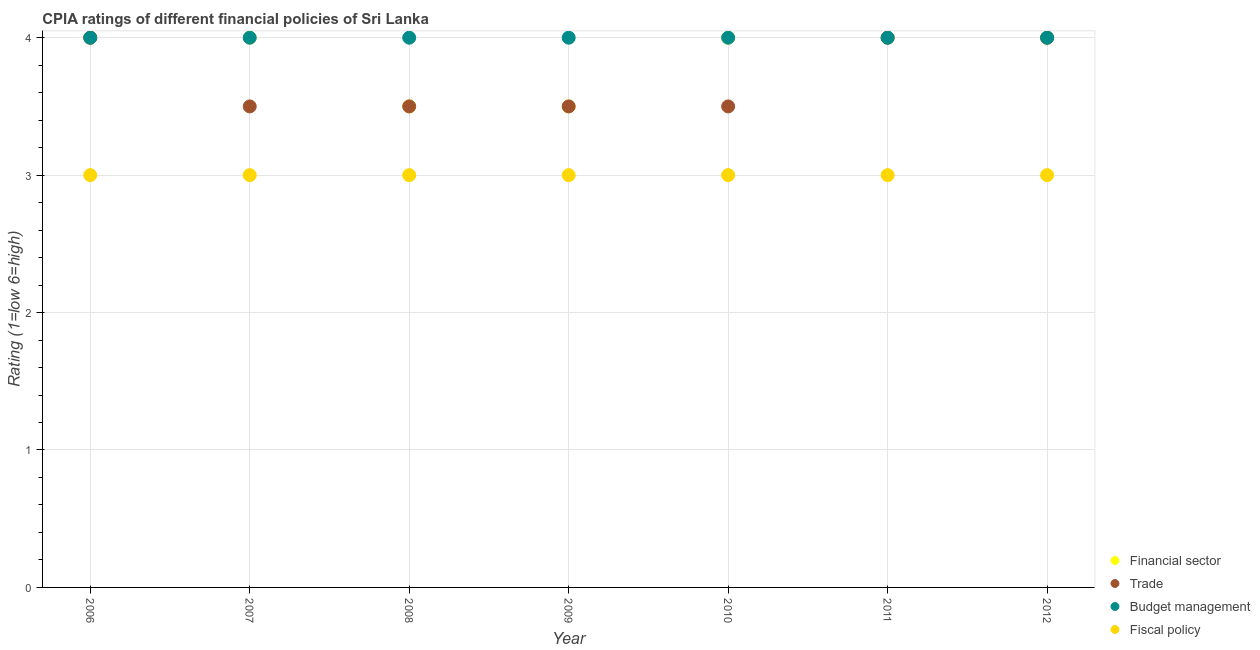What is the cpia rating of fiscal policy in 2010?
Give a very brief answer. 3. Across all years, what is the maximum cpia rating of trade?
Make the answer very short. 4. Across all years, what is the minimum cpia rating of fiscal policy?
Offer a terse response. 3. What is the total cpia rating of budget management in the graph?
Your answer should be very brief. 28. What is the difference between the cpia rating of trade in 2006 and that in 2012?
Your answer should be very brief. 0. What is the difference between the cpia rating of budget management in 2010 and the cpia rating of financial sector in 2008?
Give a very brief answer. 0.5. In how many years, is the cpia rating of financial sector greater than 0.2?
Provide a short and direct response. 7. What is the ratio of the cpia rating of financial sector in 2010 to that in 2011?
Provide a short and direct response. 1. What is the difference between the highest and the lowest cpia rating of financial sector?
Ensure brevity in your answer.  0.5. In how many years, is the cpia rating of trade greater than the average cpia rating of trade taken over all years?
Provide a succinct answer. 3. Is the sum of the cpia rating of fiscal policy in 2006 and 2010 greater than the maximum cpia rating of trade across all years?
Your answer should be compact. Yes. Is it the case that in every year, the sum of the cpia rating of financial sector and cpia rating of trade is greater than the cpia rating of budget management?
Offer a very short reply. Yes. Is the cpia rating of trade strictly less than the cpia rating of budget management over the years?
Offer a very short reply. No. How many dotlines are there?
Your answer should be compact. 4. How many years are there in the graph?
Your answer should be compact. 7. Are the values on the major ticks of Y-axis written in scientific E-notation?
Your answer should be very brief. No. How many legend labels are there?
Provide a succinct answer. 4. What is the title of the graph?
Keep it short and to the point. CPIA ratings of different financial policies of Sri Lanka. What is the label or title of the Y-axis?
Provide a short and direct response. Rating (1=low 6=high). What is the Rating (1=low 6=high) of Financial sector in 2006?
Provide a succinct answer. 4. What is the Rating (1=low 6=high) in Budget management in 2006?
Provide a succinct answer. 4. What is the Rating (1=low 6=high) in Fiscal policy in 2006?
Make the answer very short. 3. What is the Rating (1=low 6=high) in Financial sector in 2007?
Offer a terse response. 4. What is the Rating (1=low 6=high) of Budget management in 2008?
Offer a very short reply. 4. What is the Rating (1=low 6=high) of Fiscal policy in 2008?
Your answer should be very brief. 3. What is the Rating (1=low 6=high) of Trade in 2009?
Your response must be concise. 3.5. What is the Rating (1=low 6=high) in Budget management in 2009?
Your answer should be compact. 4. What is the Rating (1=low 6=high) of Fiscal policy in 2009?
Your answer should be compact. 3. What is the Rating (1=low 6=high) of Trade in 2010?
Ensure brevity in your answer.  3.5. What is the Rating (1=low 6=high) in Fiscal policy in 2010?
Keep it short and to the point. 3. What is the Rating (1=low 6=high) of Financial sector in 2011?
Provide a succinct answer. 4. What is the Rating (1=low 6=high) in Fiscal policy in 2011?
Provide a succinct answer. 3. What is the Rating (1=low 6=high) of Financial sector in 2012?
Offer a terse response. 4. What is the Rating (1=low 6=high) of Trade in 2012?
Your answer should be compact. 4. Across all years, what is the maximum Rating (1=low 6=high) in Financial sector?
Offer a very short reply. 4. Across all years, what is the maximum Rating (1=low 6=high) in Fiscal policy?
Offer a very short reply. 3. Across all years, what is the minimum Rating (1=low 6=high) of Financial sector?
Your response must be concise. 3.5. What is the total Rating (1=low 6=high) of Trade in the graph?
Make the answer very short. 26. What is the total Rating (1=low 6=high) of Budget management in the graph?
Offer a terse response. 28. What is the total Rating (1=low 6=high) in Fiscal policy in the graph?
Make the answer very short. 21. What is the difference between the Rating (1=low 6=high) of Fiscal policy in 2006 and that in 2007?
Make the answer very short. 0. What is the difference between the Rating (1=low 6=high) in Fiscal policy in 2006 and that in 2008?
Provide a short and direct response. 0. What is the difference between the Rating (1=low 6=high) of Financial sector in 2006 and that in 2009?
Your answer should be very brief. 0.5. What is the difference between the Rating (1=low 6=high) of Fiscal policy in 2006 and that in 2009?
Make the answer very short. 0. What is the difference between the Rating (1=low 6=high) in Financial sector in 2006 and that in 2010?
Your answer should be very brief. 0. What is the difference between the Rating (1=low 6=high) in Trade in 2006 and that in 2010?
Offer a terse response. 0.5. What is the difference between the Rating (1=low 6=high) in Financial sector in 2006 and that in 2011?
Give a very brief answer. 0. What is the difference between the Rating (1=low 6=high) in Trade in 2006 and that in 2011?
Provide a short and direct response. 0. What is the difference between the Rating (1=low 6=high) of Financial sector in 2006 and that in 2012?
Make the answer very short. 0. What is the difference between the Rating (1=low 6=high) in Trade in 2006 and that in 2012?
Your response must be concise. 0. What is the difference between the Rating (1=low 6=high) in Budget management in 2006 and that in 2012?
Your answer should be compact. 0. What is the difference between the Rating (1=low 6=high) of Financial sector in 2007 and that in 2008?
Offer a very short reply. 0.5. What is the difference between the Rating (1=low 6=high) of Financial sector in 2007 and that in 2009?
Offer a terse response. 0.5. What is the difference between the Rating (1=low 6=high) in Fiscal policy in 2007 and that in 2009?
Keep it short and to the point. 0. What is the difference between the Rating (1=low 6=high) in Financial sector in 2007 and that in 2010?
Make the answer very short. 0. What is the difference between the Rating (1=low 6=high) in Trade in 2007 and that in 2010?
Ensure brevity in your answer.  0. What is the difference between the Rating (1=low 6=high) in Fiscal policy in 2007 and that in 2010?
Offer a very short reply. 0. What is the difference between the Rating (1=low 6=high) of Financial sector in 2007 and that in 2011?
Ensure brevity in your answer.  0. What is the difference between the Rating (1=low 6=high) in Financial sector in 2007 and that in 2012?
Provide a succinct answer. 0. What is the difference between the Rating (1=low 6=high) in Budget management in 2007 and that in 2012?
Your response must be concise. 0. What is the difference between the Rating (1=low 6=high) in Financial sector in 2008 and that in 2009?
Give a very brief answer. 0. What is the difference between the Rating (1=low 6=high) in Budget management in 2008 and that in 2009?
Provide a short and direct response. 0. What is the difference between the Rating (1=low 6=high) in Fiscal policy in 2008 and that in 2010?
Your response must be concise. 0. What is the difference between the Rating (1=low 6=high) of Financial sector in 2008 and that in 2011?
Give a very brief answer. -0.5. What is the difference between the Rating (1=low 6=high) of Trade in 2008 and that in 2011?
Your answer should be very brief. -0.5. What is the difference between the Rating (1=low 6=high) of Fiscal policy in 2008 and that in 2011?
Ensure brevity in your answer.  0. What is the difference between the Rating (1=low 6=high) of Financial sector in 2008 and that in 2012?
Your response must be concise. -0.5. What is the difference between the Rating (1=low 6=high) of Trade in 2008 and that in 2012?
Provide a short and direct response. -0.5. What is the difference between the Rating (1=low 6=high) of Budget management in 2008 and that in 2012?
Offer a terse response. 0. What is the difference between the Rating (1=low 6=high) in Financial sector in 2009 and that in 2010?
Your answer should be compact. -0.5. What is the difference between the Rating (1=low 6=high) in Fiscal policy in 2009 and that in 2010?
Offer a terse response. 0. What is the difference between the Rating (1=low 6=high) in Budget management in 2009 and that in 2011?
Your response must be concise. 0. What is the difference between the Rating (1=low 6=high) of Trade in 2009 and that in 2012?
Provide a short and direct response. -0.5. What is the difference between the Rating (1=low 6=high) in Budget management in 2009 and that in 2012?
Give a very brief answer. 0. What is the difference between the Rating (1=low 6=high) in Fiscal policy in 2009 and that in 2012?
Offer a terse response. 0. What is the difference between the Rating (1=low 6=high) in Budget management in 2010 and that in 2011?
Provide a short and direct response. 0. What is the difference between the Rating (1=low 6=high) in Fiscal policy in 2010 and that in 2011?
Your response must be concise. 0. What is the difference between the Rating (1=low 6=high) in Financial sector in 2011 and that in 2012?
Provide a succinct answer. 0. What is the difference between the Rating (1=low 6=high) in Budget management in 2011 and that in 2012?
Offer a very short reply. 0. What is the difference between the Rating (1=low 6=high) of Fiscal policy in 2011 and that in 2012?
Keep it short and to the point. 0. What is the difference between the Rating (1=low 6=high) in Financial sector in 2006 and the Rating (1=low 6=high) in Budget management in 2007?
Give a very brief answer. 0. What is the difference between the Rating (1=low 6=high) of Financial sector in 2006 and the Rating (1=low 6=high) of Fiscal policy in 2007?
Your answer should be compact. 1. What is the difference between the Rating (1=low 6=high) of Trade in 2006 and the Rating (1=low 6=high) of Budget management in 2007?
Make the answer very short. 0. What is the difference between the Rating (1=low 6=high) of Trade in 2006 and the Rating (1=low 6=high) of Fiscal policy in 2007?
Give a very brief answer. 1. What is the difference between the Rating (1=low 6=high) of Budget management in 2006 and the Rating (1=low 6=high) of Fiscal policy in 2007?
Your response must be concise. 1. What is the difference between the Rating (1=low 6=high) in Financial sector in 2006 and the Rating (1=low 6=high) in Trade in 2008?
Give a very brief answer. 0.5. What is the difference between the Rating (1=low 6=high) of Budget management in 2006 and the Rating (1=low 6=high) of Fiscal policy in 2008?
Give a very brief answer. 1. What is the difference between the Rating (1=low 6=high) of Financial sector in 2006 and the Rating (1=low 6=high) of Trade in 2009?
Offer a very short reply. 0.5. What is the difference between the Rating (1=low 6=high) of Trade in 2006 and the Rating (1=low 6=high) of Budget management in 2009?
Your answer should be very brief. 0. What is the difference between the Rating (1=low 6=high) of Budget management in 2006 and the Rating (1=low 6=high) of Fiscal policy in 2009?
Your answer should be compact. 1. What is the difference between the Rating (1=low 6=high) in Financial sector in 2006 and the Rating (1=low 6=high) in Trade in 2010?
Make the answer very short. 0.5. What is the difference between the Rating (1=low 6=high) in Financial sector in 2006 and the Rating (1=low 6=high) in Budget management in 2010?
Keep it short and to the point. 0. What is the difference between the Rating (1=low 6=high) in Financial sector in 2006 and the Rating (1=low 6=high) in Fiscal policy in 2010?
Offer a very short reply. 1. What is the difference between the Rating (1=low 6=high) in Trade in 2006 and the Rating (1=low 6=high) in Budget management in 2010?
Keep it short and to the point. 0. What is the difference between the Rating (1=low 6=high) in Trade in 2006 and the Rating (1=low 6=high) in Fiscal policy in 2010?
Your answer should be compact. 1. What is the difference between the Rating (1=low 6=high) in Financial sector in 2006 and the Rating (1=low 6=high) in Budget management in 2011?
Give a very brief answer. 0. What is the difference between the Rating (1=low 6=high) in Financial sector in 2006 and the Rating (1=low 6=high) in Fiscal policy in 2011?
Your answer should be very brief. 1. What is the difference between the Rating (1=low 6=high) in Trade in 2006 and the Rating (1=low 6=high) in Fiscal policy in 2011?
Keep it short and to the point. 1. What is the difference between the Rating (1=low 6=high) in Budget management in 2006 and the Rating (1=low 6=high) in Fiscal policy in 2011?
Offer a very short reply. 1. What is the difference between the Rating (1=low 6=high) of Financial sector in 2006 and the Rating (1=low 6=high) of Fiscal policy in 2012?
Keep it short and to the point. 1. What is the difference between the Rating (1=low 6=high) of Trade in 2006 and the Rating (1=low 6=high) of Budget management in 2012?
Your answer should be very brief. 0. What is the difference between the Rating (1=low 6=high) of Financial sector in 2007 and the Rating (1=low 6=high) of Fiscal policy in 2008?
Your response must be concise. 1. What is the difference between the Rating (1=low 6=high) in Trade in 2007 and the Rating (1=low 6=high) in Budget management in 2008?
Keep it short and to the point. -0.5. What is the difference between the Rating (1=low 6=high) in Financial sector in 2007 and the Rating (1=low 6=high) in Trade in 2009?
Your answer should be compact. 0.5. What is the difference between the Rating (1=low 6=high) of Financial sector in 2007 and the Rating (1=low 6=high) of Fiscal policy in 2009?
Ensure brevity in your answer.  1. What is the difference between the Rating (1=low 6=high) of Budget management in 2007 and the Rating (1=low 6=high) of Fiscal policy in 2009?
Keep it short and to the point. 1. What is the difference between the Rating (1=low 6=high) in Financial sector in 2007 and the Rating (1=low 6=high) in Trade in 2010?
Provide a short and direct response. 0.5. What is the difference between the Rating (1=low 6=high) of Budget management in 2007 and the Rating (1=low 6=high) of Fiscal policy in 2010?
Ensure brevity in your answer.  1. What is the difference between the Rating (1=low 6=high) in Financial sector in 2007 and the Rating (1=low 6=high) in Fiscal policy in 2011?
Provide a short and direct response. 1. What is the difference between the Rating (1=low 6=high) of Budget management in 2007 and the Rating (1=low 6=high) of Fiscal policy in 2011?
Offer a terse response. 1. What is the difference between the Rating (1=low 6=high) of Financial sector in 2007 and the Rating (1=low 6=high) of Budget management in 2012?
Provide a succinct answer. 0. What is the difference between the Rating (1=low 6=high) in Trade in 2007 and the Rating (1=low 6=high) in Fiscal policy in 2012?
Offer a terse response. 0.5. What is the difference between the Rating (1=low 6=high) in Financial sector in 2008 and the Rating (1=low 6=high) in Budget management in 2009?
Make the answer very short. -0.5. What is the difference between the Rating (1=low 6=high) of Trade in 2008 and the Rating (1=low 6=high) of Fiscal policy in 2009?
Ensure brevity in your answer.  0.5. What is the difference between the Rating (1=low 6=high) of Financial sector in 2008 and the Rating (1=low 6=high) of Trade in 2010?
Your response must be concise. 0. What is the difference between the Rating (1=low 6=high) of Trade in 2008 and the Rating (1=low 6=high) of Budget management in 2010?
Keep it short and to the point. -0.5. What is the difference between the Rating (1=low 6=high) of Trade in 2008 and the Rating (1=low 6=high) of Fiscal policy in 2010?
Provide a short and direct response. 0.5. What is the difference between the Rating (1=low 6=high) in Financial sector in 2008 and the Rating (1=low 6=high) in Trade in 2011?
Ensure brevity in your answer.  -0.5. What is the difference between the Rating (1=low 6=high) of Financial sector in 2008 and the Rating (1=low 6=high) of Fiscal policy in 2011?
Give a very brief answer. 0.5. What is the difference between the Rating (1=low 6=high) of Trade in 2008 and the Rating (1=low 6=high) of Budget management in 2011?
Ensure brevity in your answer.  -0.5. What is the difference between the Rating (1=low 6=high) of Budget management in 2008 and the Rating (1=low 6=high) of Fiscal policy in 2011?
Offer a very short reply. 1. What is the difference between the Rating (1=low 6=high) of Financial sector in 2008 and the Rating (1=low 6=high) of Trade in 2012?
Make the answer very short. -0.5. What is the difference between the Rating (1=low 6=high) of Financial sector in 2008 and the Rating (1=low 6=high) of Fiscal policy in 2012?
Your answer should be compact. 0.5. What is the difference between the Rating (1=low 6=high) of Trade in 2008 and the Rating (1=low 6=high) of Fiscal policy in 2012?
Your answer should be compact. 0.5. What is the difference between the Rating (1=low 6=high) of Trade in 2009 and the Rating (1=low 6=high) of Budget management in 2010?
Offer a terse response. -0.5. What is the difference between the Rating (1=low 6=high) in Financial sector in 2009 and the Rating (1=low 6=high) in Budget management in 2011?
Provide a succinct answer. -0.5. What is the difference between the Rating (1=low 6=high) in Trade in 2009 and the Rating (1=low 6=high) in Budget management in 2011?
Your response must be concise. -0.5. What is the difference between the Rating (1=low 6=high) of Trade in 2009 and the Rating (1=low 6=high) of Fiscal policy in 2011?
Offer a terse response. 0.5. What is the difference between the Rating (1=low 6=high) of Budget management in 2009 and the Rating (1=low 6=high) of Fiscal policy in 2011?
Ensure brevity in your answer.  1. What is the difference between the Rating (1=low 6=high) of Financial sector in 2009 and the Rating (1=low 6=high) of Fiscal policy in 2012?
Ensure brevity in your answer.  0.5. What is the difference between the Rating (1=low 6=high) in Trade in 2009 and the Rating (1=low 6=high) in Budget management in 2012?
Your answer should be very brief. -0.5. What is the difference between the Rating (1=low 6=high) in Trade in 2009 and the Rating (1=low 6=high) in Fiscal policy in 2012?
Offer a terse response. 0.5. What is the difference between the Rating (1=low 6=high) in Financial sector in 2010 and the Rating (1=low 6=high) in Trade in 2011?
Offer a very short reply. 0. What is the difference between the Rating (1=low 6=high) of Financial sector in 2010 and the Rating (1=low 6=high) of Fiscal policy in 2011?
Offer a terse response. 1. What is the difference between the Rating (1=low 6=high) in Trade in 2010 and the Rating (1=low 6=high) in Fiscal policy in 2011?
Make the answer very short. 0.5. What is the difference between the Rating (1=low 6=high) of Financial sector in 2010 and the Rating (1=low 6=high) of Trade in 2012?
Your answer should be compact. 0. What is the difference between the Rating (1=low 6=high) of Financial sector in 2010 and the Rating (1=low 6=high) of Budget management in 2012?
Offer a terse response. 0. What is the difference between the Rating (1=low 6=high) of Trade in 2010 and the Rating (1=low 6=high) of Budget management in 2012?
Your answer should be compact. -0.5. What is the difference between the Rating (1=low 6=high) in Trade in 2010 and the Rating (1=low 6=high) in Fiscal policy in 2012?
Provide a succinct answer. 0.5. What is the difference between the Rating (1=low 6=high) in Budget management in 2010 and the Rating (1=low 6=high) in Fiscal policy in 2012?
Give a very brief answer. 1. What is the difference between the Rating (1=low 6=high) of Financial sector in 2011 and the Rating (1=low 6=high) of Budget management in 2012?
Provide a succinct answer. 0. What is the difference between the Rating (1=low 6=high) in Financial sector in 2011 and the Rating (1=low 6=high) in Fiscal policy in 2012?
Make the answer very short. 1. What is the average Rating (1=low 6=high) in Financial sector per year?
Provide a succinct answer. 3.86. What is the average Rating (1=low 6=high) of Trade per year?
Offer a terse response. 3.71. What is the average Rating (1=low 6=high) of Budget management per year?
Your response must be concise. 4. In the year 2006, what is the difference between the Rating (1=low 6=high) in Financial sector and Rating (1=low 6=high) in Budget management?
Keep it short and to the point. 0. In the year 2006, what is the difference between the Rating (1=low 6=high) in Trade and Rating (1=low 6=high) in Budget management?
Ensure brevity in your answer.  0. In the year 2007, what is the difference between the Rating (1=low 6=high) of Financial sector and Rating (1=low 6=high) of Fiscal policy?
Provide a succinct answer. 1. In the year 2007, what is the difference between the Rating (1=low 6=high) in Trade and Rating (1=low 6=high) in Budget management?
Offer a terse response. -0.5. In the year 2008, what is the difference between the Rating (1=low 6=high) of Financial sector and Rating (1=low 6=high) of Trade?
Your answer should be very brief. 0. In the year 2008, what is the difference between the Rating (1=low 6=high) in Financial sector and Rating (1=low 6=high) in Budget management?
Provide a succinct answer. -0.5. In the year 2008, what is the difference between the Rating (1=low 6=high) of Financial sector and Rating (1=low 6=high) of Fiscal policy?
Keep it short and to the point. 0.5. In the year 2008, what is the difference between the Rating (1=low 6=high) in Trade and Rating (1=low 6=high) in Fiscal policy?
Provide a succinct answer. 0.5. In the year 2009, what is the difference between the Rating (1=low 6=high) in Financial sector and Rating (1=low 6=high) in Trade?
Your response must be concise. 0. In the year 2009, what is the difference between the Rating (1=low 6=high) of Financial sector and Rating (1=low 6=high) of Budget management?
Your response must be concise. -0.5. In the year 2009, what is the difference between the Rating (1=low 6=high) of Financial sector and Rating (1=low 6=high) of Fiscal policy?
Your response must be concise. 0.5. In the year 2010, what is the difference between the Rating (1=low 6=high) of Financial sector and Rating (1=low 6=high) of Trade?
Offer a terse response. 0.5. In the year 2010, what is the difference between the Rating (1=low 6=high) of Financial sector and Rating (1=low 6=high) of Budget management?
Keep it short and to the point. 0. In the year 2010, what is the difference between the Rating (1=low 6=high) of Financial sector and Rating (1=low 6=high) of Fiscal policy?
Provide a short and direct response. 1. In the year 2010, what is the difference between the Rating (1=low 6=high) of Trade and Rating (1=low 6=high) of Fiscal policy?
Keep it short and to the point. 0.5. In the year 2011, what is the difference between the Rating (1=low 6=high) of Financial sector and Rating (1=low 6=high) of Trade?
Your answer should be compact. 0. In the year 2011, what is the difference between the Rating (1=low 6=high) in Financial sector and Rating (1=low 6=high) in Fiscal policy?
Your answer should be very brief. 1. In the year 2011, what is the difference between the Rating (1=low 6=high) of Trade and Rating (1=low 6=high) of Budget management?
Give a very brief answer. 0. In the year 2011, what is the difference between the Rating (1=low 6=high) of Trade and Rating (1=low 6=high) of Fiscal policy?
Keep it short and to the point. 1. In the year 2012, what is the difference between the Rating (1=low 6=high) of Financial sector and Rating (1=low 6=high) of Trade?
Offer a very short reply. 0. In the year 2012, what is the difference between the Rating (1=low 6=high) in Trade and Rating (1=low 6=high) in Fiscal policy?
Your answer should be very brief. 1. What is the ratio of the Rating (1=low 6=high) in Fiscal policy in 2006 to that in 2007?
Make the answer very short. 1. What is the ratio of the Rating (1=low 6=high) in Financial sector in 2006 to that in 2008?
Keep it short and to the point. 1.14. What is the ratio of the Rating (1=low 6=high) of Trade in 2006 to that in 2008?
Offer a very short reply. 1.14. What is the ratio of the Rating (1=low 6=high) in Trade in 2006 to that in 2009?
Offer a terse response. 1.14. What is the ratio of the Rating (1=low 6=high) of Budget management in 2006 to that in 2009?
Offer a very short reply. 1. What is the ratio of the Rating (1=low 6=high) in Fiscal policy in 2006 to that in 2009?
Provide a short and direct response. 1. What is the ratio of the Rating (1=low 6=high) of Financial sector in 2006 to that in 2010?
Provide a short and direct response. 1. What is the ratio of the Rating (1=low 6=high) of Trade in 2006 to that in 2010?
Keep it short and to the point. 1.14. What is the ratio of the Rating (1=low 6=high) in Fiscal policy in 2006 to that in 2010?
Provide a short and direct response. 1. What is the ratio of the Rating (1=low 6=high) in Budget management in 2006 to that in 2011?
Your answer should be compact. 1. What is the ratio of the Rating (1=low 6=high) of Budget management in 2006 to that in 2012?
Provide a succinct answer. 1. What is the ratio of the Rating (1=low 6=high) in Trade in 2007 to that in 2008?
Your answer should be very brief. 1. What is the ratio of the Rating (1=low 6=high) of Budget management in 2007 to that in 2008?
Keep it short and to the point. 1. What is the ratio of the Rating (1=low 6=high) of Fiscal policy in 2007 to that in 2008?
Provide a short and direct response. 1. What is the ratio of the Rating (1=low 6=high) of Financial sector in 2007 to that in 2009?
Keep it short and to the point. 1.14. What is the ratio of the Rating (1=low 6=high) in Trade in 2007 to that in 2009?
Offer a very short reply. 1. What is the ratio of the Rating (1=low 6=high) of Financial sector in 2007 to that in 2010?
Provide a short and direct response. 1. What is the ratio of the Rating (1=low 6=high) in Budget management in 2007 to that in 2010?
Keep it short and to the point. 1. What is the ratio of the Rating (1=low 6=high) of Fiscal policy in 2007 to that in 2010?
Your answer should be compact. 1. What is the ratio of the Rating (1=low 6=high) in Budget management in 2007 to that in 2011?
Offer a very short reply. 1. What is the ratio of the Rating (1=low 6=high) of Fiscal policy in 2007 to that in 2011?
Provide a short and direct response. 1. What is the ratio of the Rating (1=low 6=high) of Budget management in 2007 to that in 2012?
Offer a terse response. 1. What is the ratio of the Rating (1=low 6=high) in Fiscal policy in 2007 to that in 2012?
Your response must be concise. 1. What is the ratio of the Rating (1=low 6=high) in Financial sector in 2008 to that in 2009?
Keep it short and to the point. 1. What is the ratio of the Rating (1=low 6=high) of Trade in 2008 to that in 2009?
Your answer should be very brief. 1. What is the ratio of the Rating (1=low 6=high) of Financial sector in 2008 to that in 2010?
Your answer should be very brief. 0.88. What is the ratio of the Rating (1=low 6=high) of Financial sector in 2008 to that in 2011?
Your response must be concise. 0.88. What is the ratio of the Rating (1=low 6=high) in Trade in 2008 to that in 2011?
Offer a terse response. 0.88. What is the ratio of the Rating (1=low 6=high) in Fiscal policy in 2008 to that in 2011?
Your answer should be very brief. 1. What is the ratio of the Rating (1=low 6=high) of Fiscal policy in 2008 to that in 2012?
Keep it short and to the point. 1. What is the ratio of the Rating (1=low 6=high) of Trade in 2009 to that in 2010?
Your answer should be compact. 1. What is the ratio of the Rating (1=low 6=high) in Trade in 2009 to that in 2011?
Make the answer very short. 0.88. What is the ratio of the Rating (1=low 6=high) in Budget management in 2009 to that in 2011?
Offer a terse response. 1. What is the ratio of the Rating (1=low 6=high) in Financial sector in 2009 to that in 2012?
Your answer should be very brief. 0.88. What is the ratio of the Rating (1=low 6=high) in Trade in 2009 to that in 2012?
Make the answer very short. 0.88. What is the ratio of the Rating (1=low 6=high) in Financial sector in 2010 to that in 2011?
Your answer should be very brief. 1. What is the ratio of the Rating (1=low 6=high) of Trade in 2010 to that in 2011?
Ensure brevity in your answer.  0.88. What is the ratio of the Rating (1=low 6=high) in Budget management in 2010 to that in 2011?
Make the answer very short. 1. What is the ratio of the Rating (1=low 6=high) in Fiscal policy in 2010 to that in 2011?
Your response must be concise. 1. What is the ratio of the Rating (1=low 6=high) of Trade in 2010 to that in 2012?
Offer a very short reply. 0.88. What is the ratio of the Rating (1=low 6=high) of Fiscal policy in 2010 to that in 2012?
Your answer should be compact. 1. What is the ratio of the Rating (1=low 6=high) of Budget management in 2011 to that in 2012?
Provide a short and direct response. 1. What is the ratio of the Rating (1=low 6=high) in Fiscal policy in 2011 to that in 2012?
Ensure brevity in your answer.  1. What is the difference between the highest and the second highest Rating (1=low 6=high) in Financial sector?
Your answer should be compact. 0. What is the difference between the highest and the second highest Rating (1=low 6=high) in Fiscal policy?
Keep it short and to the point. 0. What is the difference between the highest and the lowest Rating (1=low 6=high) of Financial sector?
Ensure brevity in your answer.  0.5. What is the difference between the highest and the lowest Rating (1=low 6=high) in Trade?
Provide a succinct answer. 0.5. What is the difference between the highest and the lowest Rating (1=low 6=high) in Budget management?
Ensure brevity in your answer.  0. 